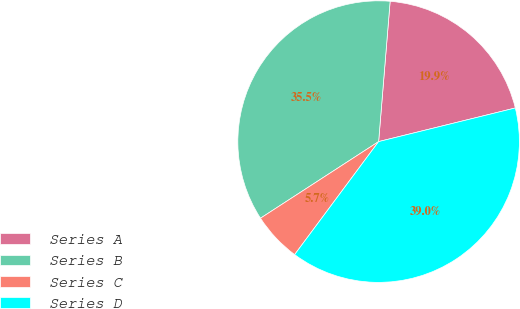Convert chart. <chart><loc_0><loc_0><loc_500><loc_500><pie_chart><fcel>Series A<fcel>Series B<fcel>Series C<fcel>Series D<nl><fcel>19.86%<fcel>35.46%<fcel>5.67%<fcel>39.01%<nl></chart> 